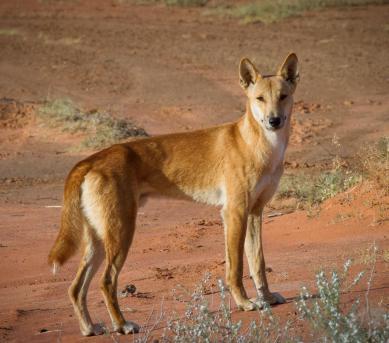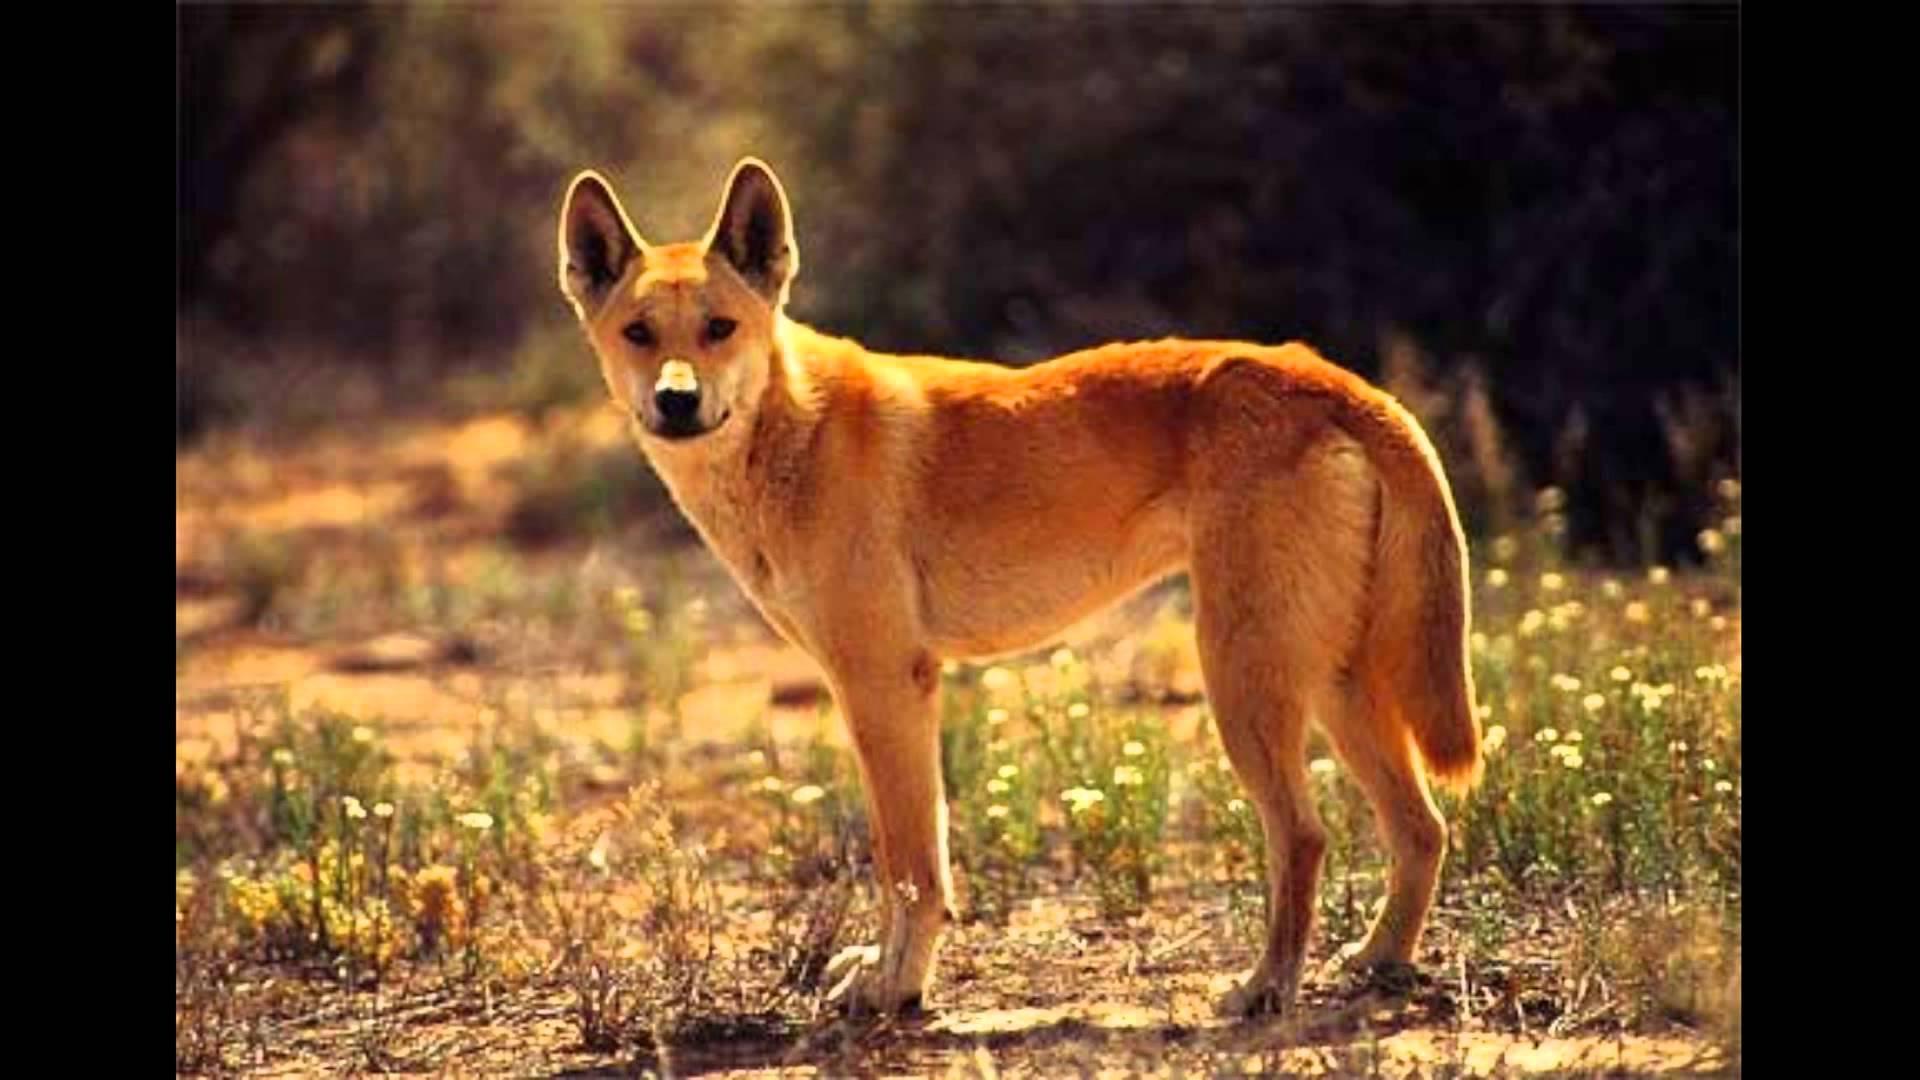The first image is the image on the left, the second image is the image on the right. Examine the images to the left and right. Is the description "Each image shows only one wild dog, and the left image shows a dog with its body in profile turned rightward." accurate? Answer yes or no. Yes. The first image is the image on the left, the second image is the image on the right. Evaluate the accuracy of this statement regarding the images: "At least one image shows a single dog and no dog in any image has its mouth open.". Is it true? Answer yes or no. Yes. 